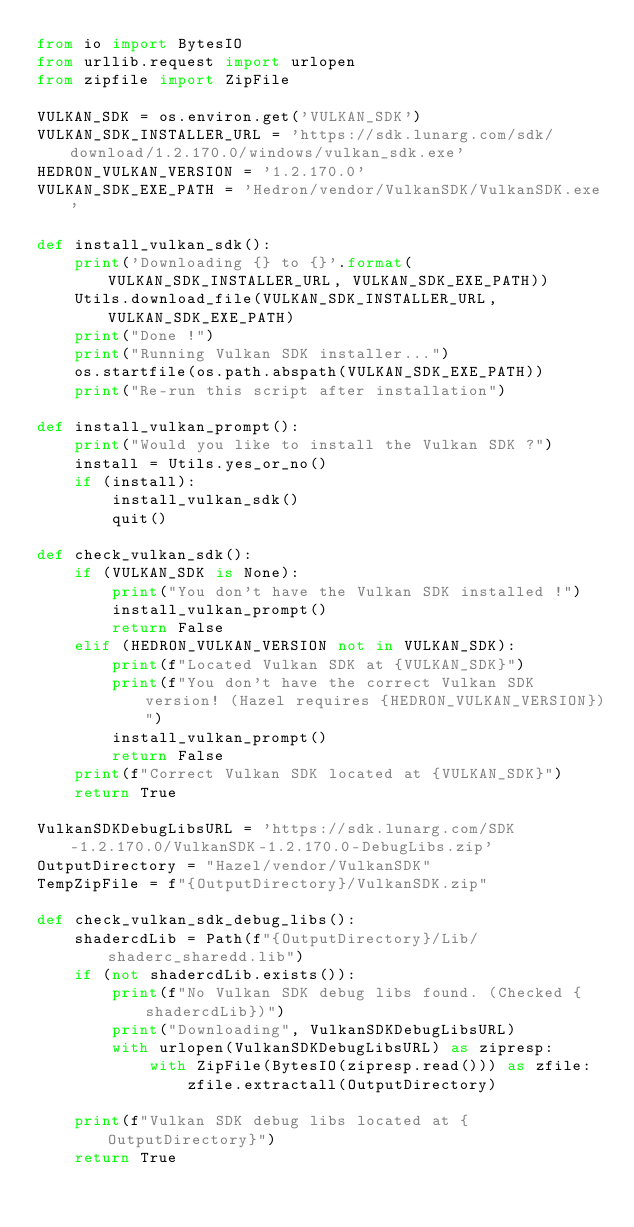<code> <loc_0><loc_0><loc_500><loc_500><_Python_>from io import BytesIO
from urllib.request import urlopen
from zipfile import ZipFile

VULKAN_SDK = os.environ.get('VULKAN_SDK')
VULKAN_SDK_INSTALLER_URL = 'https://sdk.lunarg.com/sdk/download/1.2.170.0/windows/vulkan_sdk.exe'
HEDRON_VULKAN_VERSION = '1.2.170.0'
VULKAN_SDK_EXE_PATH = 'Hedron/vendor/VulkanSDK/VulkanSDK.exe'

def install_vulkan_sdk():
	print('Downloading {} to {}'.format(VULKAN_SDK_INSTALLER_URL, VULKAN_SDK_EXE_PATH))
	Utils.download_file(VULKAN_SDK_INSTALLER_URL, VULKAN_SDK_EXE_PATH)
	print("Done !")
	print("Running Vulkan SDK installer...")
	os.startfile(os.path.abspath(VULKAN_SDK_EXE_PATH))
	print("Re-run this script after installation")

def install_vulkan_prompt():
	print("Would you like to install the Vulkan SDK ?")
	install = Utils.yes_or_no()
	if (install):
		install_vulkan_sdk()
		quit()

def check_vulkan_sdk():
	if (VULKAN_SDK is None):
		print("You don't have the Vulkan SDK installed !")
		install_vulkan_prompt()
		return False
	elif (HEDRON_VULKAN_VERSION not in VULKAN_SDK):
		print(f"Located Vulkan SDK at {VULKAN_SDK}")
		print(f"You don't have the correct Vulkan SDK version! (Hazel requires {HEDRON_VULKAN_VERSION})")
		install_vulkan_prompt()
		return False
	print(f"Correct Vulkan SDK located at {VULKAN_SDK}")
	return True

VulkanSDKDebugLibsURL = 'https://sdk.lunarg.com/SDK-1.2.170.0/VulkanSDK-1.2.170.0-DebugLibs.zip'
OutputDirectory = "Hazel/vendor/VulkanSDK"
TempZipFile = f"{OutputDirectory}/VulkanSDK.zip"

def check_vulkan_sdk_debug_libs():
	shadercdLib = Path(f"{OutputDirectory}/Lib/shaderc_sharedd.lib")
	if (not shadercdLib.exists()):
		print(f"No Vulkan SDK debug libs found. (Checked {shadercdLib})")
		print("Downloading", VulkanSDKDebugLibsURL)
		with urlopen(VulkanSDKDebugLibsURL) as zipresp:
			with ZipFile(BytesIO(zipresp.read())) as zfile:
				zfile.extractall(OutputDirectory)

	print(f"Vulkan SDK debug libs located at {OutputDirectory}")
	return True</code> 